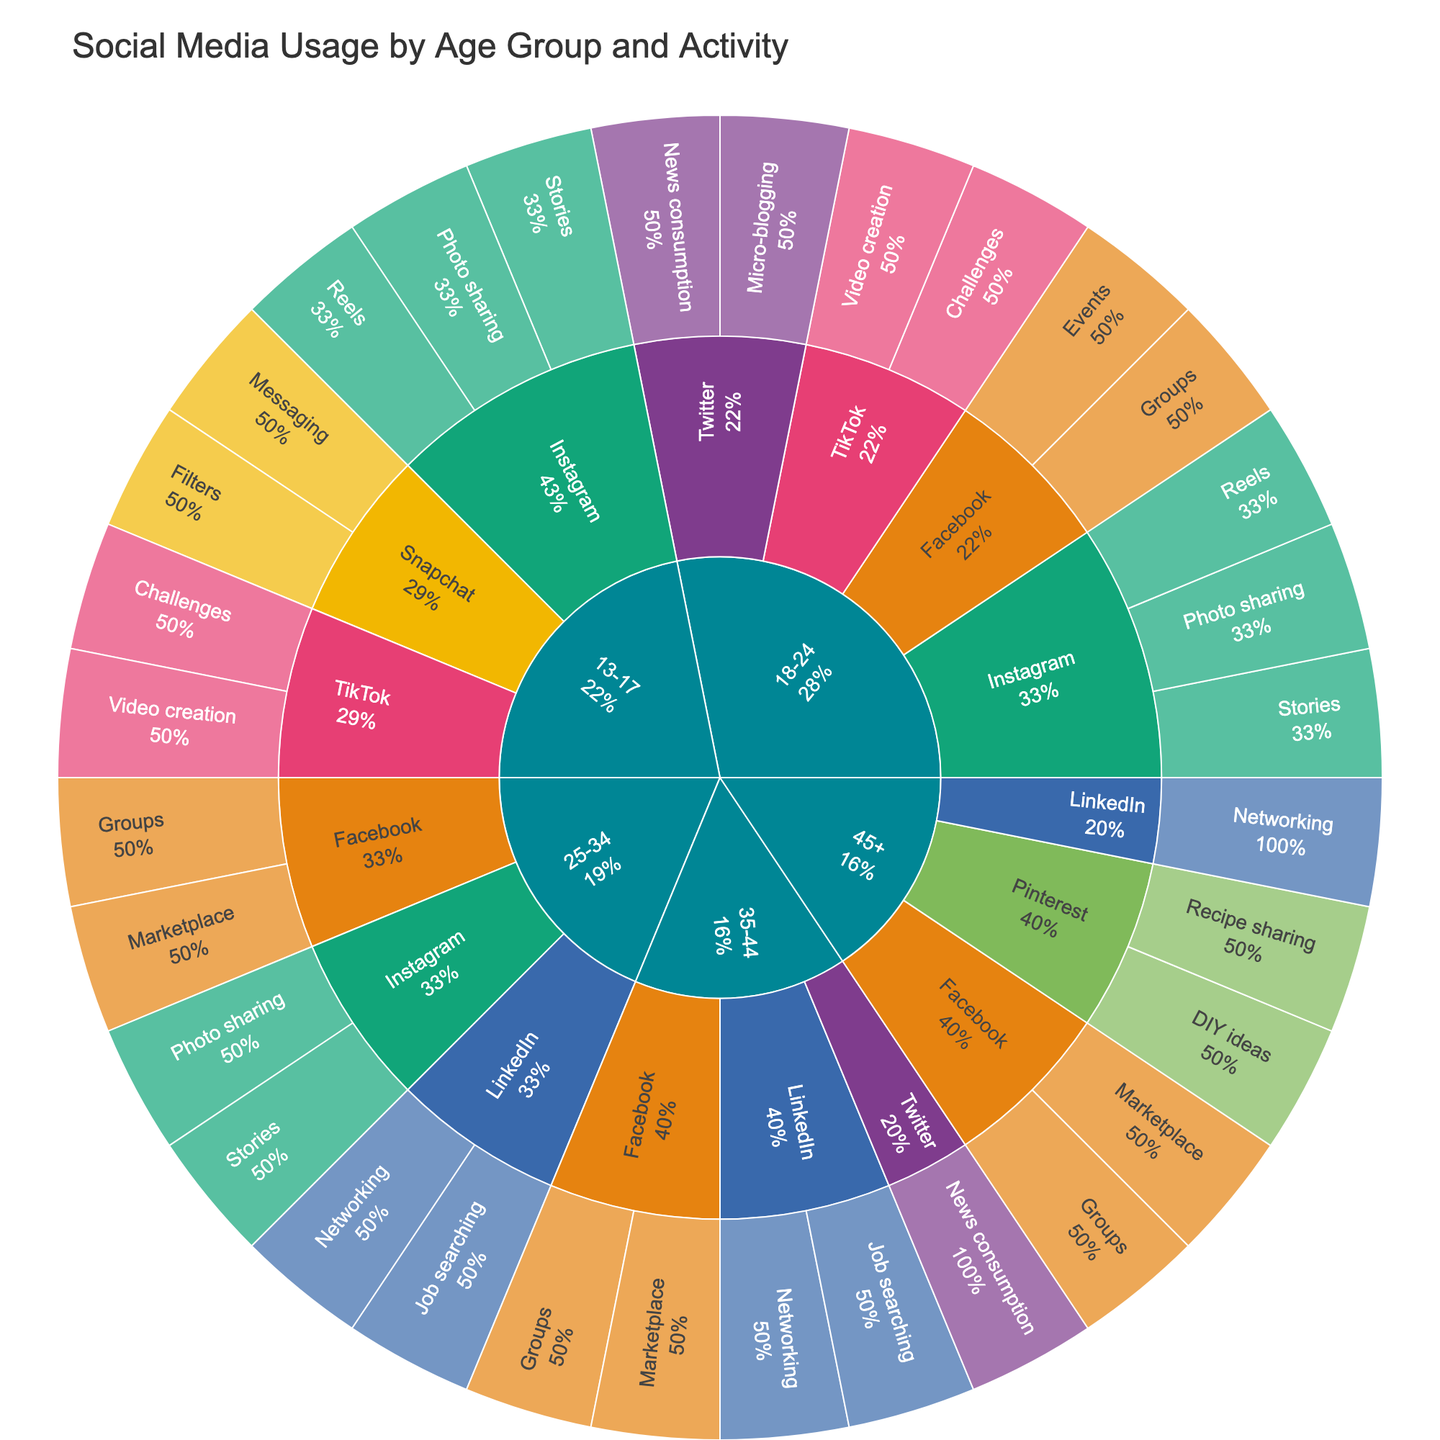what is the title of the plot? The title is the large text at the top center of the plot. It is there to provide a quick summary of what the visual represents. In this case, it helps viewers understand that the plot is about social media usage.
Answer: Social Media Usage by Age Group and Activity which age group uses the most platforms? Look at the outermost ring of the sunburst plot that has segments for each age group. The age group with the most distinct platform segments uses the most platforms.
Answer: 18-24 what activity is most popular among the 13-17 age group on TikTok? Find the segment for the 13-17 age group and then locate TikTok. Check the inner segment for TikTok to see what activities are listed. The one with the largest segment or percentage is the most popular.
Answer: Video creation how many platforms do people aged 35-44 use? Find the 35-44 segment and count the different platforms that branch out from this age group.
Answer: 3 which age group is associated only with Facebook and LinkedIn? Identify the age group segments and check which age group exclusively branches out to Facebook and LinkedIn without other platforms.
Answer: 45+ do people aged 25-34 use Instagram more than Facebook? Compare the size of the Instagram segment to the Facebook segment within the 25-34 age group to see which is larger.
Answer: No which activity in the 18-24 age group on Twitter has a larger segment: micro-blogging or news consumption? Look at the Twitter segment under the 18-24 age group and compare the sizes of the micro-blogging and news consumption segments.
Answer: Micro-blogging what social media platform is exclusively used by the 45+ age group for non-networking activities? Check the segments for the 45+ age group to identify a platform that has non-networking activities only.
Answer: Pinterest which activity is shared by both the 25-34 and 35-44 age groups on LinkedIn? Find the LinkedIn segments for both the 25-34 and 35-44 age groups and identify the activity that appears in both segments.
Answer: Job searching compare the popularity of Snapchat among 13-17 year-olds to Pinterest among 45+ year-olds. Which is more popular? Examine the size of the Snapchat segment within the 13-17 age group compared to the Pinterest segment in the 45+ age group to determine which is larger.
Answer: Snapchat among 13-17 year-olds 